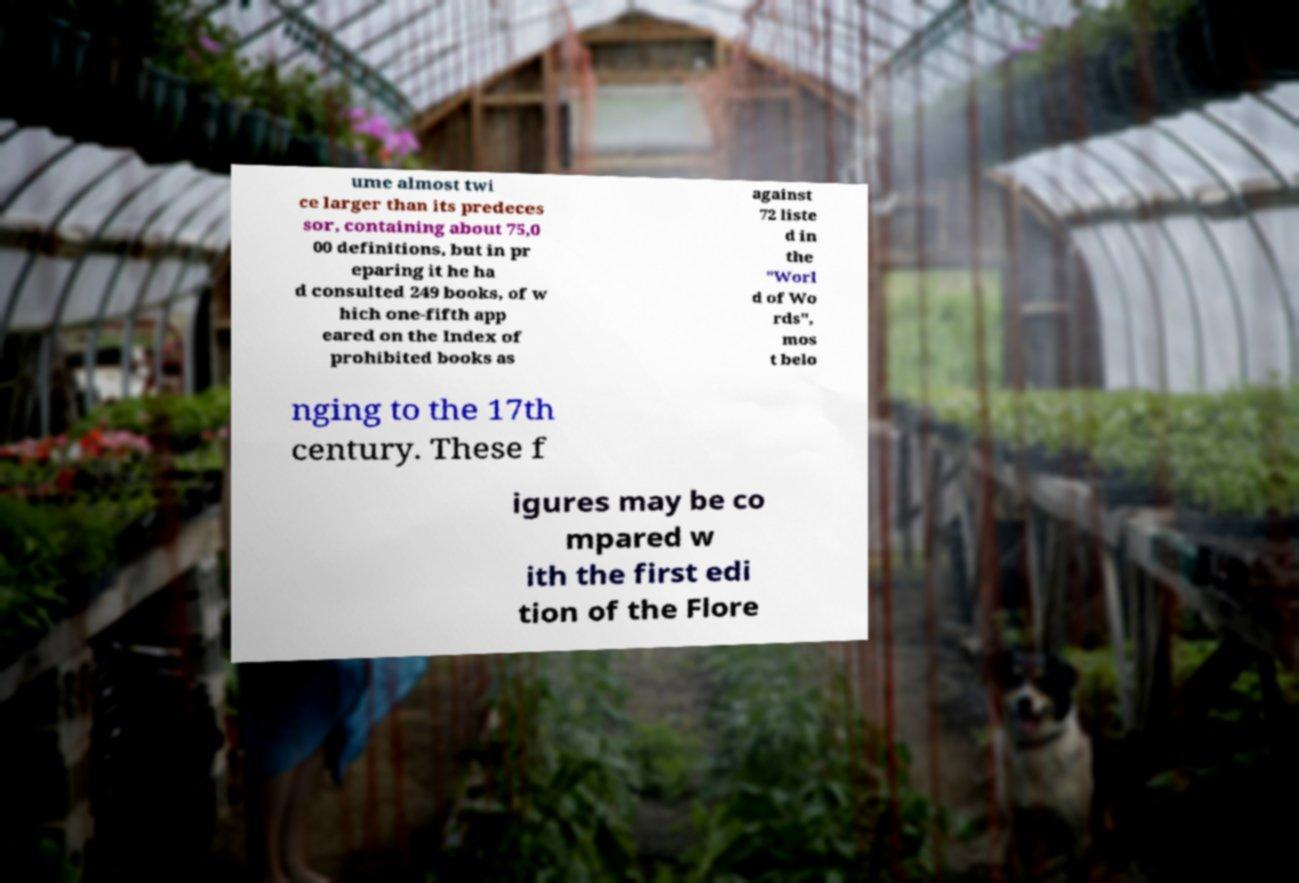Can you read and provide the text displayed in the image?This photo seems to have some interesting text. Can you extract and type it out for me? ume almost twi ce larger than its predeces sor, containing about 75,0 00 definitions, but in pr eparing it he ha d consulted 249 books, of w hich one-fifth app eared on the Index of prohibited books as against 72 liste d in the "Worl d of Wo rds", mos t belo nging to the 17th century. These f igures may be co mpared w ith the first edi tion of the Flore 